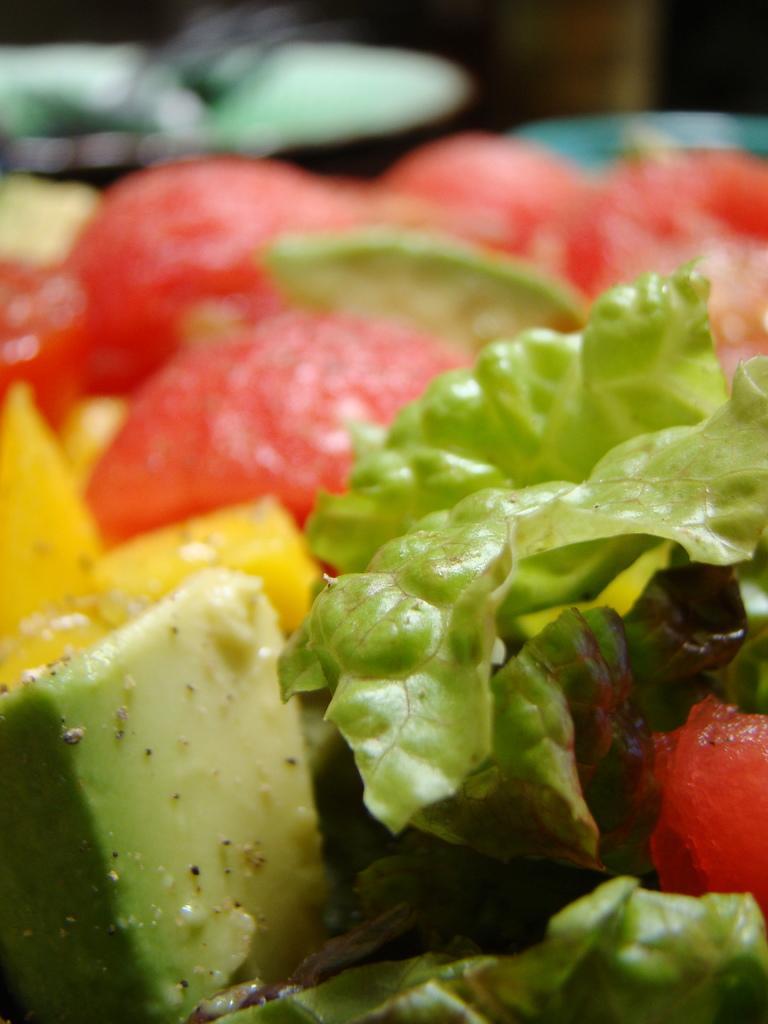In one or two sentences, can you explain what this image depicts? In the picture I can see food items. The background of the image is blurred. 